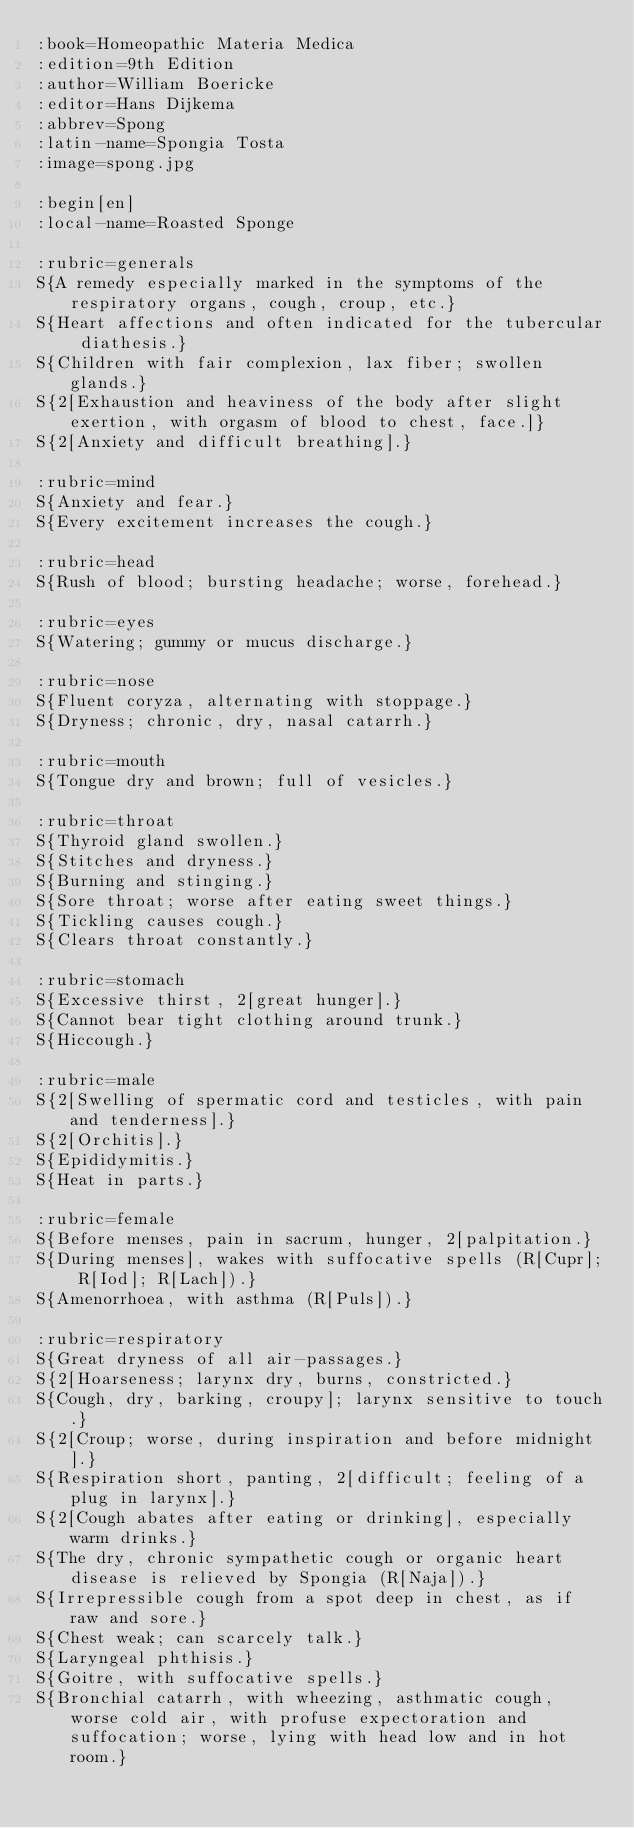Convert code to text. <code><loc_0><loc_0><loc_500><loc_500><_ObjectiveC_>:book=Homeopathic Materia Medica
:edition=9th Edition
:author=William Boericke
:editor=Hans Dijkema
:abbrev=Spong
:latin-name=Spongia Tosta
:image=spong.jpg

:begin[en]
:local-name=Roasted Sponge

:rubric=generals
S{A remedy especially marked in the symptoms of the respiratory organs, cough, croup, etc.}
S{Heart affections and often indicated for the tubercular diathesis.}
S{Children with fair complexion, lax fiber; swollen glands.}
S{2[Exhaustion and heaviness of the body after slight exertion, with orgasm of blood to chest, face.]}
S{2[Anxiety and difficult breathing].}

:rubric=mind
S{Anxiety and fear.}
S{Every excitement increases the cough.}

:rubric=head
S{Rush of blood; bursting headache; worse, forehead.}

:rubric=eyes
S{Watering; gummy or mucus discharge.}

:rubric=nose
S{Fluent coryza, alternating with stoppage.}
S{Dryness; chronic, dry, nasal catarrh.}

:rubric=mouth
S{Tongue dry and brown; full of vesicles.}

:rubric=throat
S{Thyroid gland swollen.}
S{Stitches and dryness.}
S{Burning and stinging.}
S{Sore throat; worse after eating sweet things.}
S{Tickling causes cough.}
S{Clears throat constantly.}

:rubric=stomach
S{Excessive thirst, 2[great hunger].}
S{Cannot bear tight clothing around trunk.}
S{Hiccough.}

:rubric=male
S{2[Swelling of spermatic cord and testicles, with pain and tenderness].}
S{2[Orchitis].}
S{Epididymitis.}
S{Heat in parts.}

:rubric=female
S{Before menses, pain in sacrum, hunger, 2[palpitation.}
S{During menses], wakes with suffocative spells (R[Cupr]; R[Iod]; R[Lach]).}
S{Amenorrhoea, with asthma (R[Puls]).}

:rubric=respiratory
S{Great dryness of all air-passages.}
S{2[Hoarseness; larynx dry, burns, constricted.}
S{Cough, dry, barking, croupy]; larynx sensitive to touch.}
S{2[Croup; worse, during inspiration and before midnight].}
S{Respiration short, panting, 2[difficult; feeling of a plug in larynx].}
S{2[Cough abates after eating or drinking], especially warm drinks.}
S{The dry, chronic sympathetic cough or organic heart disease is relieved by Spongia (R[Naja]).}
S{Irrepressible cough from a spot deep in chest, as if raw and sore.}
S{Chest weak; can scarcely talk.}
S{Laryngeal phthisis.}
S{Goitre, with suffocative spells.}
S{Bronchial catarrh, with wheezing, asthmatic cough, worse cold air, with profuse expectoration and suffocation; worse, lying with head low and in hot room.}</code> 